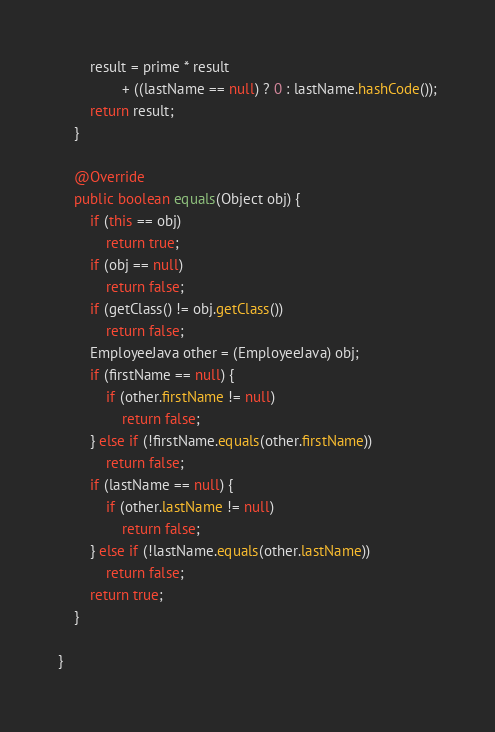Convert code to text. <code><loc_0><loc_0><loc_500><loc_500><_Java_>		result = prime * result
				+ ((lastName == null) ? 0 : lastName.hashCode());
		return result;
	}

	@Override
	public boolean equals(Object obj) {
		if (this == obj)
			return true;
		if (obj == null)
			return false;
		if (getClass() != obj.getClass())
			return false;
		EmployeeJava other = (EmployeeJava) obj;
		if (firstName == null) {
			if (other.firstName != null)
				return false;
		} else if (!firstName.equals(other.firstName))
			return false;
		if (lastName == null) {
			if (other.lastName != null)
				return false;
		} else if (!lastName.equals(other.lastName))
			return false;
		return true;
	}
	
}
</code> 